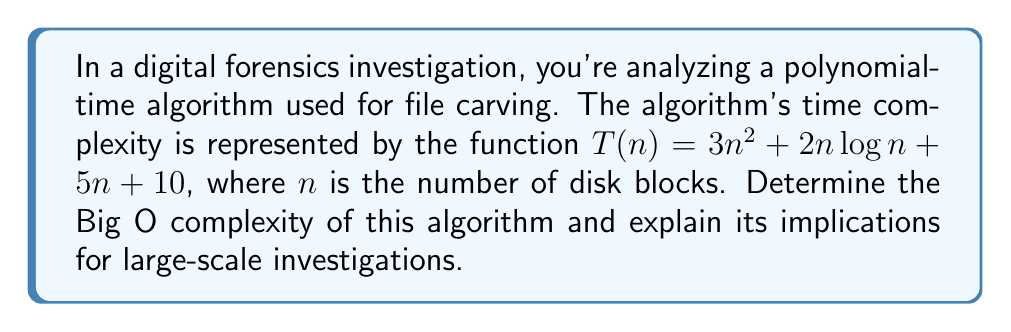Give your solution to this math problem. To determine the Big O complexity of the given function $T(n) = 3n^2 + 2n\log n + 5n + 10$, we need to identify the dominant term as $n$ approaches infinity. Let's analyze each term:

1. $3n^2$: This is a quadratic term.
2. $2n\log n$: This is a linearithmic term.
3. $5n$: This is a linear term.
4. $10$: This is a constant term.

As $n$ grows larger, the quadratic term $3n^2$ will dominate all other terms. We can demonstrate this by comparing the growth rates:

$$\lim_{n \to \infty} \frac{n\log n}{n^2} = \lim_{n \to \infty} \frac{\log n}{n} = 0$$
$$\lim_{n \to \infty} \frac{n}{n^2} = \lim_{n \to \infty} \frac{1}{n} = 0$$
$$\lim_{n \to \infty} \frac{1}{n^2} = 0$$

These limits show that as $n$ approaches infinity, the quadratic term grows faster than all other terms in the function.

In Big O notation, we ignore constant factors and lower-order terms. Therefore, we can simplify $3n^2$ to $n^2$.

Implications for large-scale investigations:
1. The quadratic complexity means that as the number of disk blocks (n) increases, the processing time will grow quadratically.
2. This could lead to significant time constraints for very large datasets, potentially limiting the algorithm's practicality for extremely large-scale investigations.
3. Investigators should consider the trade-off between thoroughness and time efficiency when dealing with substantial amounts of data.
4. For future research, it may be beneficial to explore more efficient algorithms with lower complexity (e.g., linearithmic or linear) for large-scale digital forensics tasks.
Answer: The Big O complexity of the given algorithm is $O(n^2)$. 